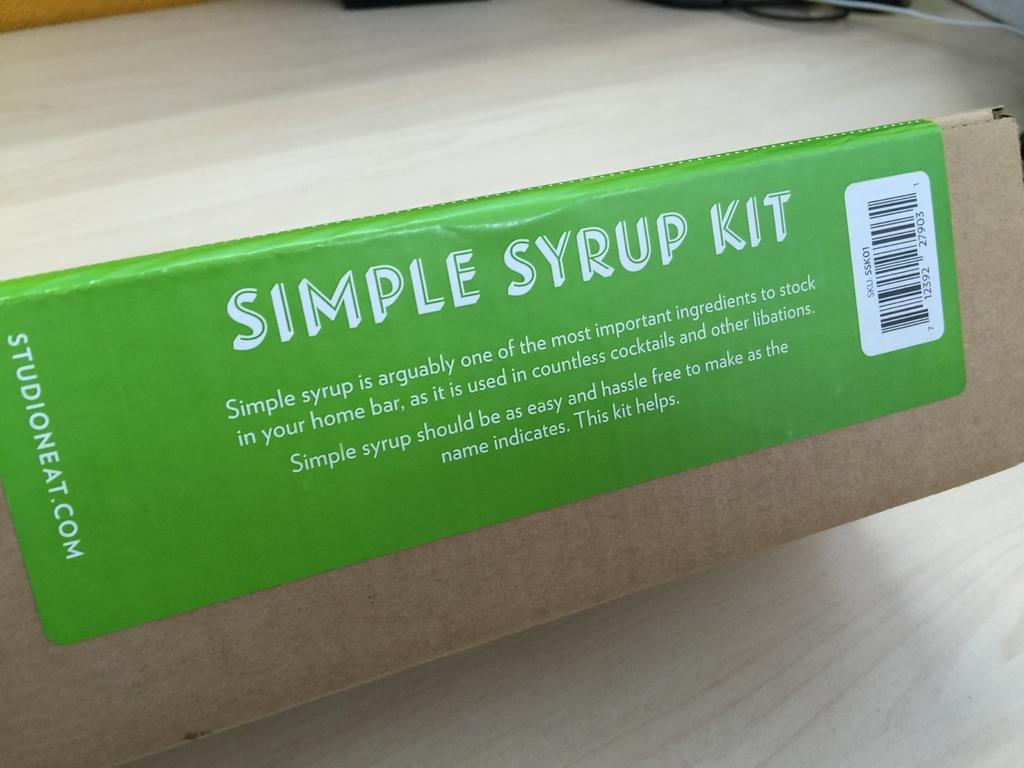<image>
Offer a succinct explanation of the picture presented. A box with a green label that reads Simple syrup kit. 